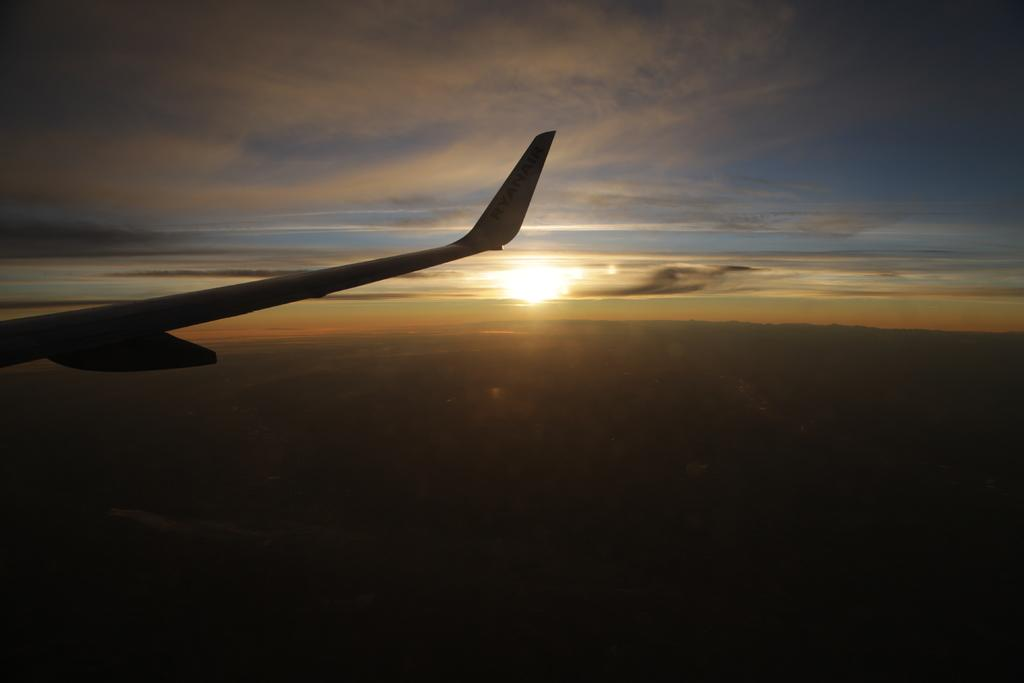What type of aircraft part can be seen in the image? There is a body part of an aircraft in the image. What can be seen in the background of the image? The sky is visible in the image, with clouds and the sun present. How would you describe the lighting at the bottom of the image? The bottom of the image is dark. How much salt is sprinkled on the aircraft part in the image? There is no salt present in the image; it is a body part of an aircraft with a sky background. 